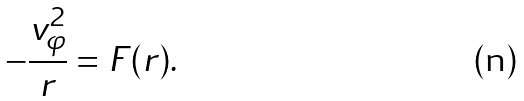Convert formula to latex. <formula><loc_0><loc_0><loc_500><loc_500>- \frac { v _ { \varphi } ^ { 2 } } { r } = F ( r ) .</formula> 